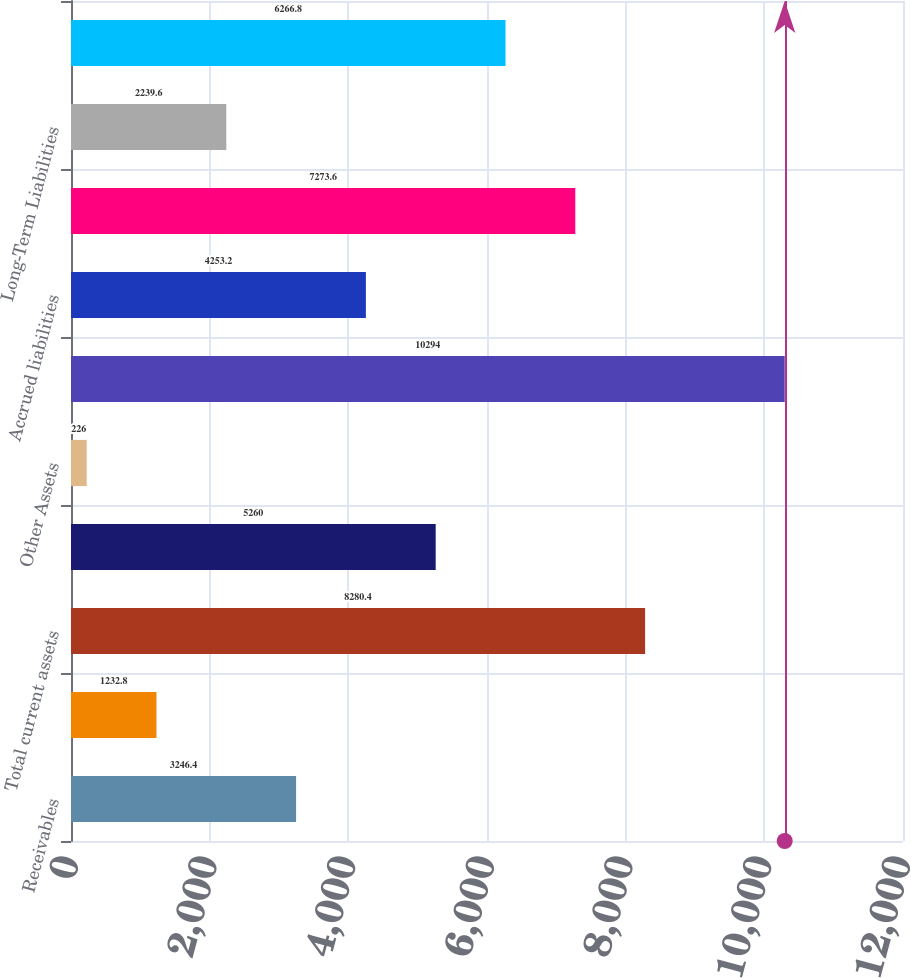<chart> <loc_0><loc_0><loc_500><loc_500><bar_chart><fcel>Receivables<fcel>Other current assets<fcel>Total current assets<fcel>Net Property and Equipment<fcel>Other Assets<fcel>Total Assets<fcel>Accrued liabilities<fcel>Total current liabilities<fcel>Long-Term Liabilities<fcel>Shareholders' Equity<nl><fcel>3246.4<fcel>1232.8<fcel>8280.4<fcel>5260<fcel>226<fcel>10294<fcel>4253.2<fcel>7273.6<fcel>2239.6<fcel>6266.8<nl></chart> 